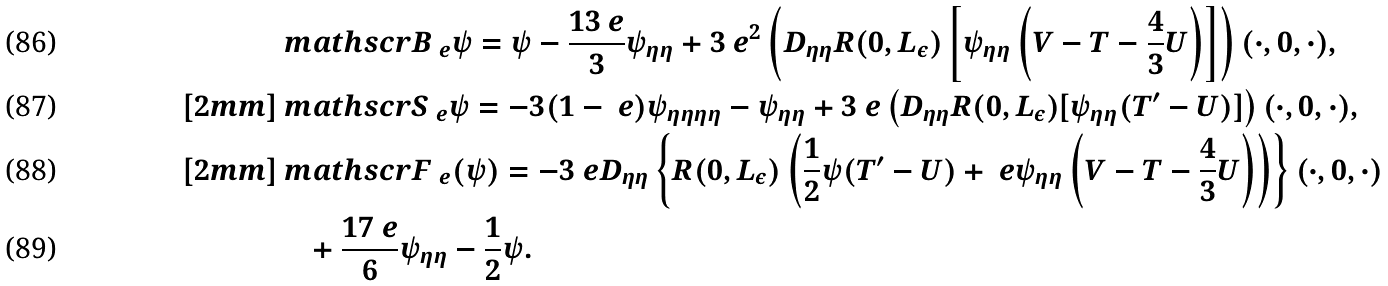<formula> <loc_0><loc_0><loc_500><loc_500>& { \ m a t h s c r B } _ { \ e } \psi = \psi - \frac { 1 3 \ e } { 3 } \psi _ { \eta \eta } + 3 \ e ^ { 2 } \left ( D _ { \eta \eta } R ( 0 , L _ { \varepsilon } ) \left [ \psi _ { \eta \eta } \left ( { V } - { T } - \frac { 4 } { 3 } { U } \right ) \right ] \right ) ( \cdot , 0 , \cdot ) , \\ [ 2 m m ] & { \ m a t h s c r S } _ { \ e } \psi = - 3 ( 1 - \ e ) \psi _ { \eta \eta \eta \eta } - \psi _ { \eta \eta } + 3 \ e \left ( D _ { \eta \eta } R ( 0 , L _ { \varepsilon } ) [ \psi _ { \eta \eta } ( { T } ^ { \prime } - { U } ) ] \right ) ( \cdot , 0 , \cdot ) , \\ [ 2 m m ] & { \ m a t h s c r F } _ { \ e } ( \psi ) = - 3 \ e D _ { \eta \eta } \left \{ R ( 0 , L _ { \varepsilon } ) \left ( \frac { 1 } { 2 } \psi ( { T } ^ { \prime } - { U } ) + \ e \psi _ { \eta \eta } \left ( { V } - { T } - \frac { 4 } { 3 } { U } \right ) \right ) \right \} ( \cdot , 0 , \cdot ) \\ & \quad + \frac { 1 7 \ e } { 6 } \psi _ { \eta \eta } - \frac { 1 } { 2 } \psi .</formula> 